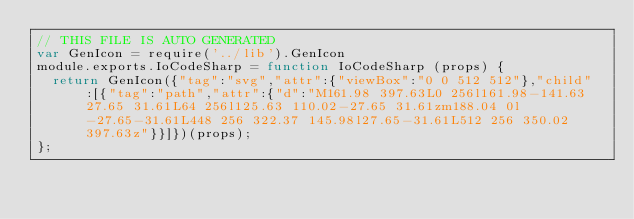Convert code to text. <code><loc_0><loc_0><loc_500><loc_500><_JavaScript_>// THIS FILE IS AUTO GENERATED
var GenIcon = require('../lib').GenIcon
module.exports.IoCodeSharp = function IoCodeSharp (props) {
  return GenIcon({"tag":"svg","attr":{"viewBox":"0 0 512 512"},"child":[{"tag":"path","attr":{"d":"M161.98 397.63L0 256l161.98-141.63 27.65 31.61L64 256l125.63 110.02-27.65 31.61zm188.04 0l-27.65-31.61L448 256 322.37 145.98l27.65-31.61L512 256 350.02 397.63z"}}]})(props);
};
</code> 